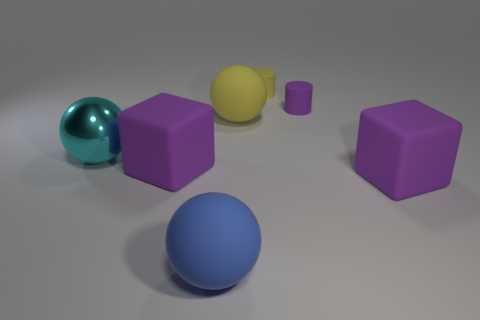Add 3 blue rubber spheres. How many objects exist? 10 Subtract all cylinders. How many objects are left? 5 Add 6 big yellow things. How many big yellow things are left? 7 Add 6 small purple rubber cylinders. How many small purple rubber cylinders exist? 7 Subtract 0 green spheres. How many objects are left? 7 Subtract all tiny blue rubber things. Subtract all large blocks. How many objects are left? 5 